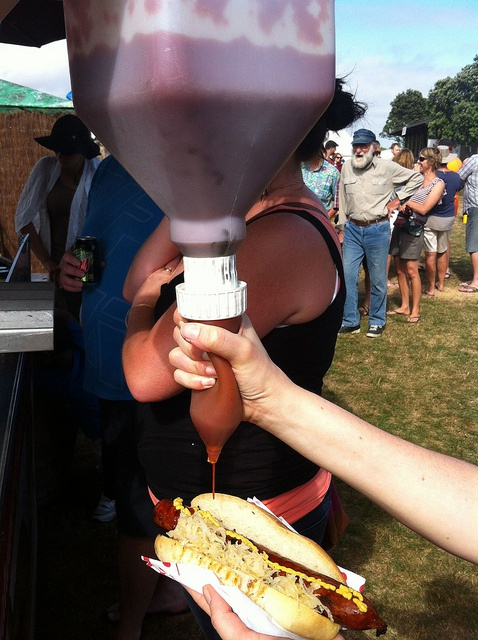Describe the objects in this image and their specific colors. I can see people in black, maroon, brown, and salmon tones, people in black, beige, tan, and salmon tones, people in black, navy, maroon, and gray tones, hot dog in black, khaki, lightyellow, and maroon tones, and people in black, lightgray, gray, and darkgray tones in this image. 